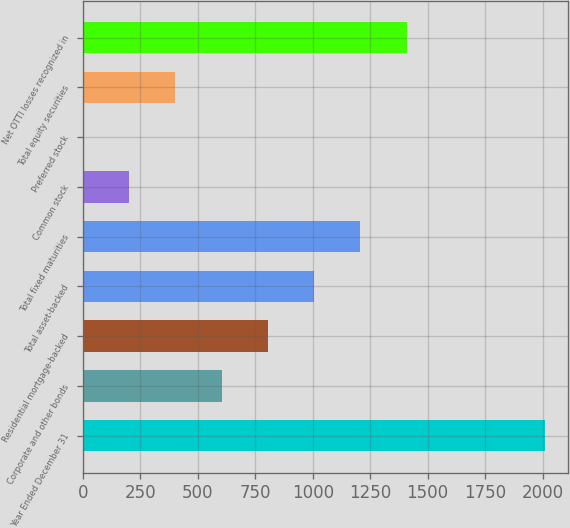Convert chart. <chart><loc_0><loc_0><loc_500><loc_500><bar_chart><fcel>Year Ended December 31<fcel>Corporate and other bonds<fcel>Residential mortgage-backed<fcel>Total asset-backed<fcel>Total fixed maturities<fcel>Common stock<fcel>Preferred stock<fcel>Total equity securities<fcel>Net OTTI losses recognized in<nl><fcel>2011<fcel>604<fcel>805<fcel>1006<fcel>1207<fcel>202<fcel>1<fcel>403<fcel>1408<nl></chart> 